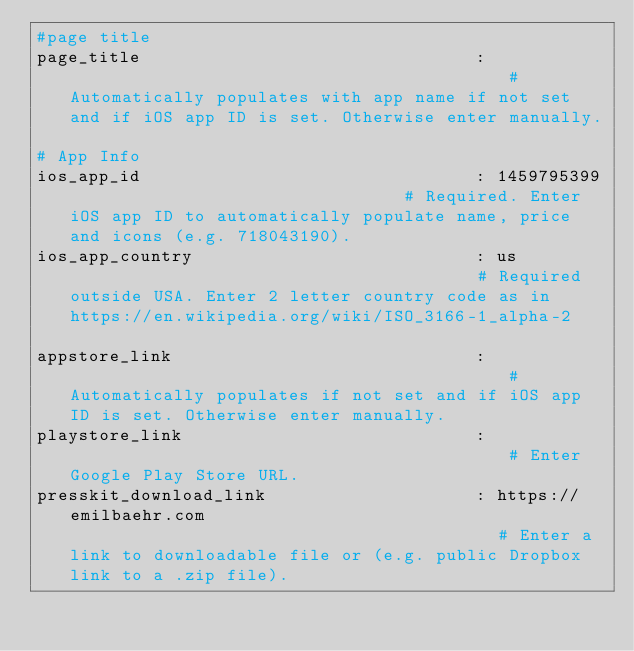Convert code to text. <code><loc_0><loc_0><loc_500><loc_500><_YAML_>#page title
page_title                                :                                           # Automatically populates with app name if not set and if iOS app ID is set. Otherwise enter manually.

# App Info
ios_app_id                                : 1459795399                                # Required. Enter iOS app ID to automatically populate name, price and icons (e.g. 718043190).
ios_app_country                           : us                                        # Required outside USA. Enter 2 letter country code as in https://en.wikipedia.org/wiki/ISO_3166-1_alpha-2

appstore_link                             :                                           # Automatically populates if not set and if iOS app ID is set. Otherwise enter manually.
playstore_link                            :                                           # Enter Google Play Store URL.
presskit_download_link                    : https://emilbaehr.com                                          # Enter a link to downloadable file or (e.g. public Dropbox link to a .zip file). </code> 